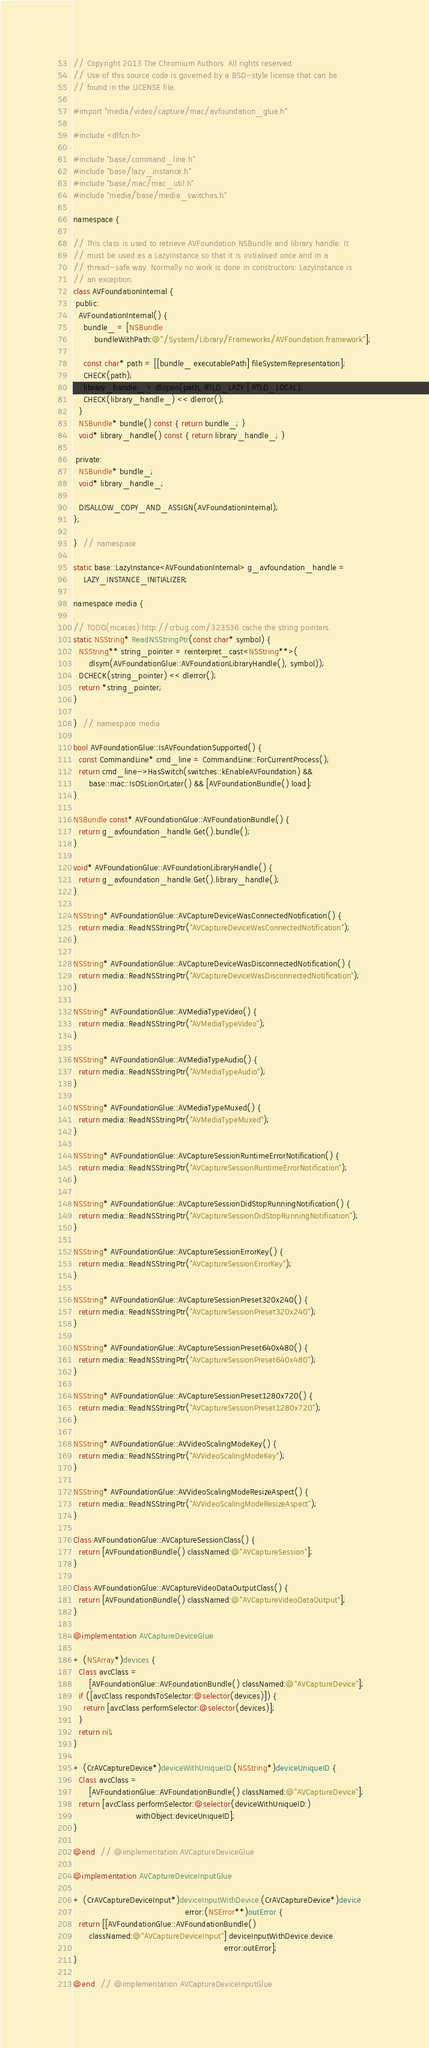<code> <loc_0><loc_0><loc_500><loc_500><_ObjectiveC_>// Copyright 2013 The Chromium Authors. All rights reserved.
// Use of this source code is governed by a BSD-style license that can be
// found in the LICENSE file.

#import "media/video/capture/mac/avfoundation_glue.h"

#include <dlfcn.h>

#include "base/command_line.h"
#include "base/lazy_instance.h"
#include "base/mac/mac_util.h"
#include "media/base/media_switches.h"

namespace {

// This class is used to retrieve AVFoundation NSBundle and library handle. It
// must be used as a LazyInstance so that it is initialised once and in a
// thread-safe way. Normally no work is done in constructors: LazyInstance is
// an exception.
class AVFoundationInternal {
 public:
  AVFoundationInternal() {
    bundle_ = [NSBundle
        bundleWithPath:@"/System/Library/Frameworks/AVFoundation.framework"];

    const char* path = [[bundle_ executablePath] fileSystemRepresentation];
    CHECK(path);
    library_handle_ = dlopen(path, RTLD_LAZY | RTLD_LOCAL);
    CHECK(library_handle_) << dlerror();
  }
  NSBundle* bundle() const { return bundle_; }
  void* library_handle() const { return library_handle_; }

 private:
  NSBundle* bundle_;
  void* library_handle_;

  DISALLOW_COPY_AND_ASSIGN(AVFoundationInternal);
};

}  // namespace

static base::LazyInstance<AVFoundationInternal> g_avfoundation_handle =
    LAZY_INSTANCE_INITIALIZER;

namespace media {

// TODO(mcasas):http://crbug.com/323536 cache the string pointers.
static NSString* ReadNSStringPtr(const char* symbol) {
  NSString** string_pointer = reinterpret_cast<NSString**>(
      dlsym(AVFoundationGlue::AVFoundationLibraryHandle(), symbol));
  DCHECK(string_pointer) << dlerror();
  return *string_pointer;
}

}  // namespace media

bool AVFoundationGlue::IsAVFoundationSupported() {
  const CommandLine* cmd_line = CommandLine::ForCurrentProcess();
  return cmd_line->HasSwitch(switches::kEnableAVFoundation) &&
      base::mac::IsOSLionOrLater() && [AVFoundationBundle() load];
}

NSBundle const* AVFoundationGlue::AVFoundationBundle() {
  return g_avfoundation_handle.Get().bundle();
}

void* AVFoundationGlue::AVFoundationLibraryHandle() {
  return g_avfoundation_handle.Get().library_handle();
}

NSString* AVFoundationGlue::AVCaptureDeviceWasConnectedNotification() {
  return media::ReadNSStringPtr("AVCaptureDeviceWasConnectedNotification");
}

NSString* AVFoundationGlue::AVCaptureDeviceWasDisconnectedNotification() {
  return media::ReadNSStringPtr("AVCaptureDeviceWasDisconnectedNotification");
}

NSString* AVFoundationGlue::AVMediaTypeVideo() {
  return media::ReadNSStringPtr("AVMediaTypeVideo");
}

NSString* AVFoundationGlue::AVMediaTypeAudio() {
  return media::ReadNSStringPtr("AVMediaTypeAudio");
}

NSString* AVFoundationGlue::AVMediaTypeMuxed() {
  return media::ReadNSStringPtr("AVMediaTypeMuxed");
}

NSString* AVFoundationGlue::AVCaptureSessionRuntimeErrorNotification() {
  return media::ReadNSStringPtr("AVCaptureSessionRuntimeErrorNotification");
}

NSString* AVFoundationGlue::AVCaptureSessionDidStopRunningNotification() {
  return media::ReadNSStringPtr("AVCaptureSessionDidStopRunningNotification");
}

NSString* AVFoundationGlue::AVCaptureSessionErrorKey() {
  return media::ReadNSStringPtr("AVCaptureSessionErrorKey");
}

NSString* AVFoundationGlue::AVCaptureSessionPreset320x240() {
  return media::ReadNSStringPtr("AVCaptureSessionPreset320x240");
}

NSString* AVFoundationGlue::AVCaptureSessionPreset640x480() {
  return media::ReadNSStringPtr("AVCaptureSessionPreset640x480");
}

NSString* AVFoundationGlue::AVCaptureSessionPreset1280x720() {
  return media::ReadNSStringPtr("AVCaptureSessionPreset1280x720");
}

NSString* AVFoundationGlue::AVVideoScalingModeKey() {
  return media::ReadNSStringPtr("AVVideoScalingModeKey");
}

NSString* AVFoundationGlue::AVVideoScalingModeResizeAspect() {
  return media::ReadNSStringPtr("AVVideoScalingModeResizeAspect");
}

Class AVFoundationGlue::AVCaptureSessionClass() {
  return [AVFoundationBundle() classNamed:@"AVCaptureSession"];
}

Class AVFoundationGlue::AVCaptureVideoDataOutputClass() {
  return [AVFoundationBundle() classNamed:@"AVCaptureVideoDataOutput"];
}

@implementation AVCaptureDeviceGlue

+ (NSArray*)devices {
  Class avcClass =
      [AVFoundationGlue::AVFoundationBundle() classNamed:@"AVCaptureDevice"];
  if ([avcClass respondsToSelector:@selector(devices)]) {
    return [avcClass performSelector:@selector(devices)];
  }
  return nil;
}

+ (CrAVCaptureDevice*)deviceWithUniqueID:(NSString*)deviceUniqueID {
  Class avcClass =
      [AVFoundationGlue::AVFoundationBundle() classNamed:@"AVCaptureDevice"];
  return [avcClass performSelector:@selector(deviceWithUniqueID:)
                        withObject:deviceUniqueID];
}

@end  // @implementation AVCaptureDeviceGlue

@implementation AVCaptureDeviceInputGlue

+ (CrAVCaptureDeviceInput*)deviceInputWithDevice:(CrAVCaptureDevice*)device
                                           error:(NSError**)outError {
  return [[AVFoundationGlue::AVFoundationBundle()
      classNamed:@"AVCaptureDeviceInput"] deviceInputWithDevice:device
                                                          error:outError];
}

@end  // @implementation AVCaptureDeviceInputGlue
</code> 